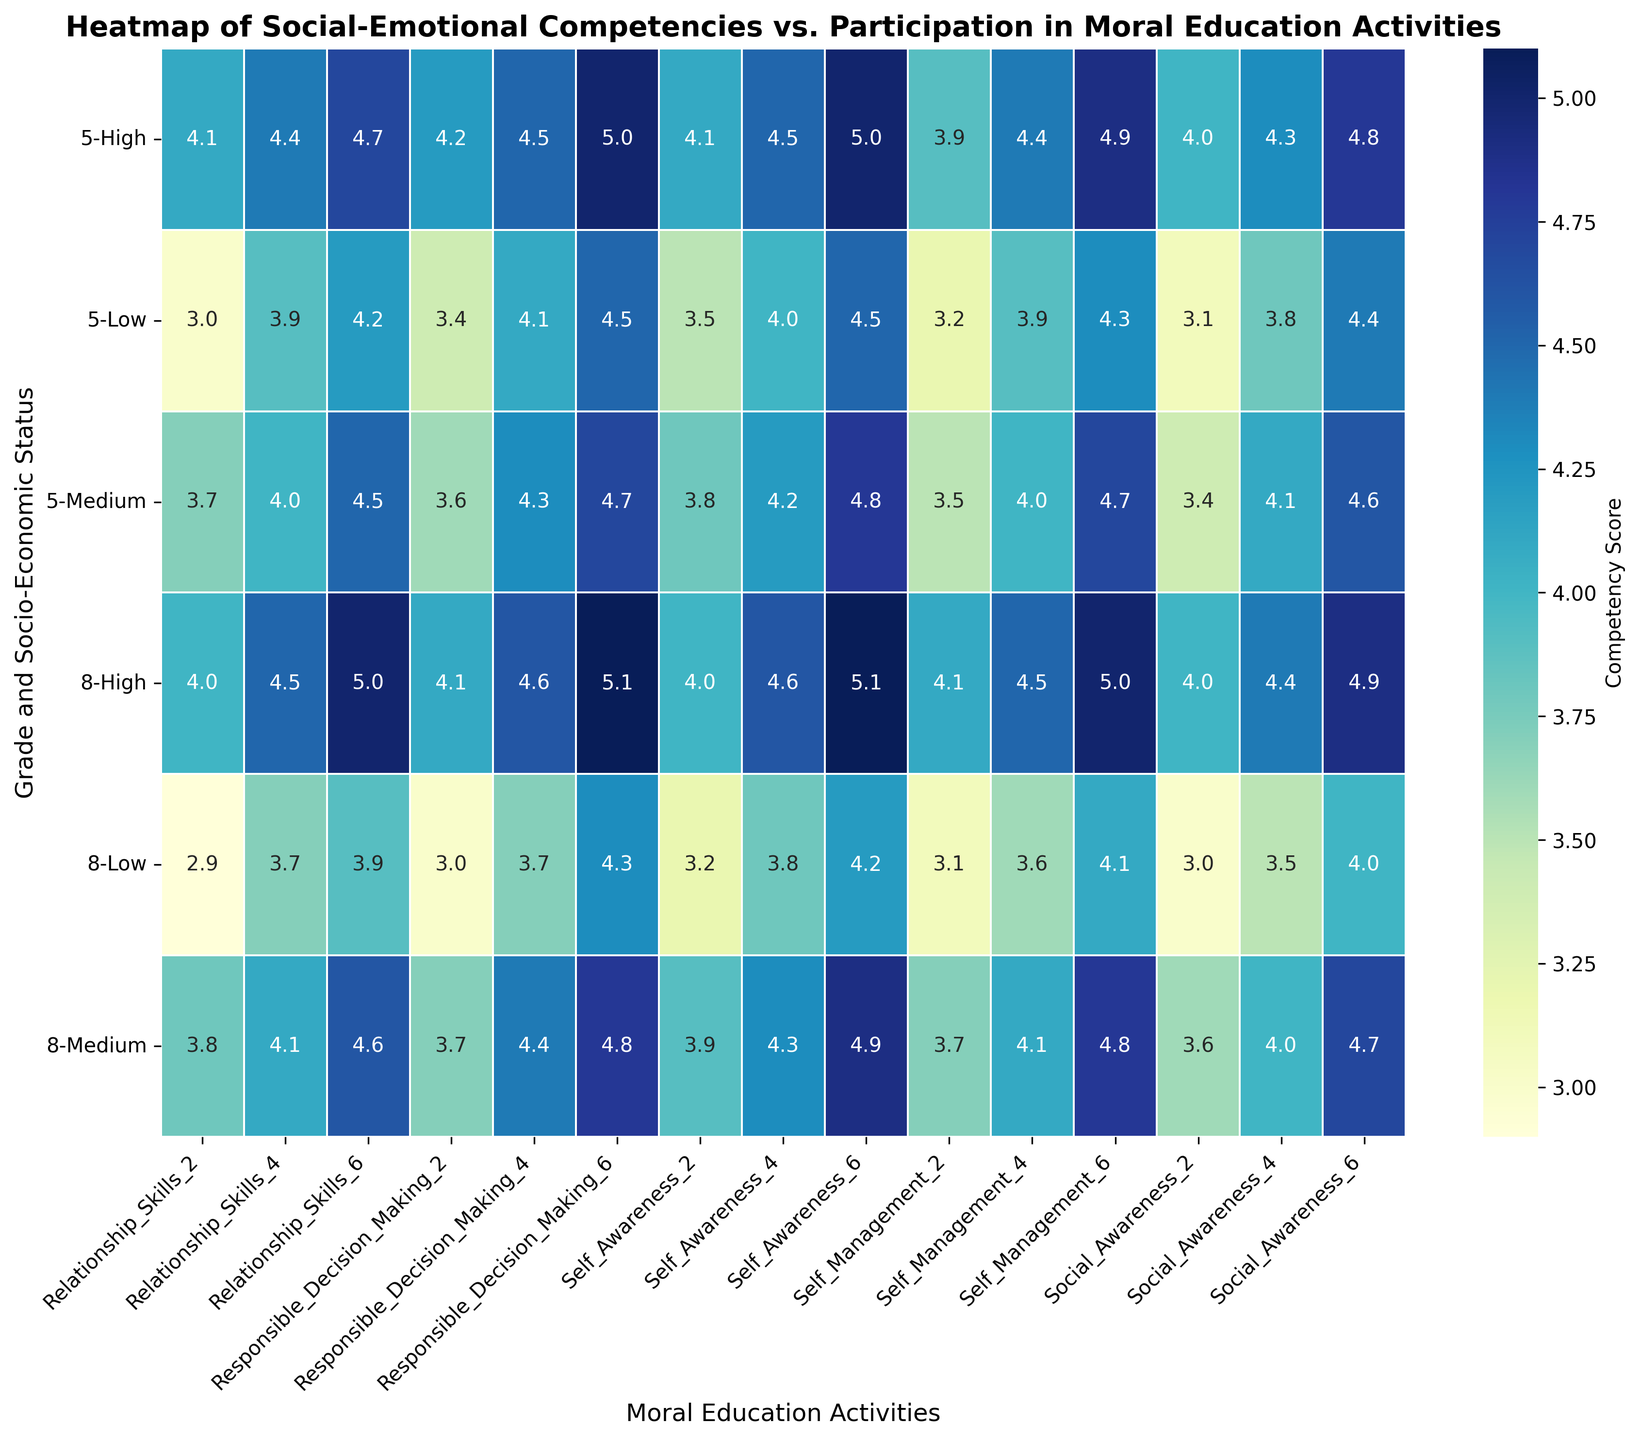What grade and SES level combination shows the highest average competency scores when participating in 6 moral education activities? To answer this, identify the highest values in the heatmap for the columns where moral education activities equal 6. Compare these values across different grade and SES level combinations.
Answer: Grade 8, High SES Which competency shows the greatest improvement for Grade 5, Low SES students when participation in moral education activities increases from 2 to 6? Check the values for Grade 5, Low SES in the columns for 2 and 6 moral education activities. Calculate the difference for each competency and determine which difference is the largest.
Answer: Self-Awareness Between Grade 5 students with Medium SES and High SES, who has a higher average Self-Management competency when participating in 4 moral education activities? Compare the Self-Management values for Grade 5 students in the Medium SES and High SES rows in the column for 4 moral education activities.
Answer: High SES Which socio-economic status shows the least variance in competency scores for Grade 8 students across all moral education activities? Calculate the variance of competency scores for each SES level in Grade 8 across different moral education activities. Compare the variances to find the smallest one.
Answer: High SES Does participation in 6 moral education activities lead to higher or lower scores in Responsible Decision-Making for Grade 8, Low SES students compared to Grade 5, Low SES students? Compare the Responsible Decision-Making scores for Grade 8, Low SES and Grade 5, Low SES in the column for 6 moral education activities.
Answer: Higher for Grade 8, Low SES How does the Relationship Skills competency change between grades for Medium SES students when participating in 2 moral education activities? Compare the Relationship Skills values for Medium SES students between the two grades in the column for 2 moral education activities.
Answer: Increases from 3.7 (Grade 5) to 3.8 (Grade 8) Which competency and socio-economic status combination has the highest score for Grade 5 students participating in 6 moral education activities? Look at the scores in the row for Grade 5 and 6 moral education activities. Identify the highest value and its corresponding competency and SES level.
Answer: Grade 5, High SES, 5.0 in Self-Awareness Between Grade 8 students of High SES and Medium SES, who has higher Social Awareness scores with 4 moral education activities? Compare the Social Awareness values for Grade 8 students in the High SES and Medium SES rows in the column for 4 moral education activities.
Answer: High SES What is the average score for Self-Awareness across all SES levels for Grade 5 students when participating in 4 moral education activities? Sum up the Self-Awareness scores for Low, Medium, and High SES levels for Grade 5 students in the 4 moral education activities column and divide by the number of SES levels (3).
Answer: 4.23 